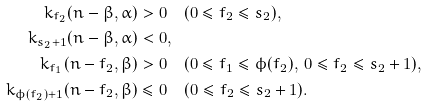Convert formula to latex. <formula><loc_0><loc_0><loc_500><loc_500>k _ { f _ { 2 } } ( n - \beta , \alpha ) & > 0 \quad ( 0 \leq f _ { 2 } \leq s _ { 2 } ) , \\ k _ { s _ { 2 } + 1 } ( n - \beta , \alpha ) & < 0 , \\ k _ { f _ { 1 } } ( n - f _ { 2 } , \beta ) & > 0 \quad ( 0 \leq f _ { 1 } \leq \phi ( f _ { 2 } ) , \, 0 \leq f _ { 2 } \leq s _ { 2 } + 1 ) , \\ k _ { \phi ( f _ { 2 } ) + 1 } ( n - f _ { 2 } , \beta ) & \leq 0 \quad ( 0 \leq f _ { 2 } \leq s _ { 2 } + 1 ) .</formula> 